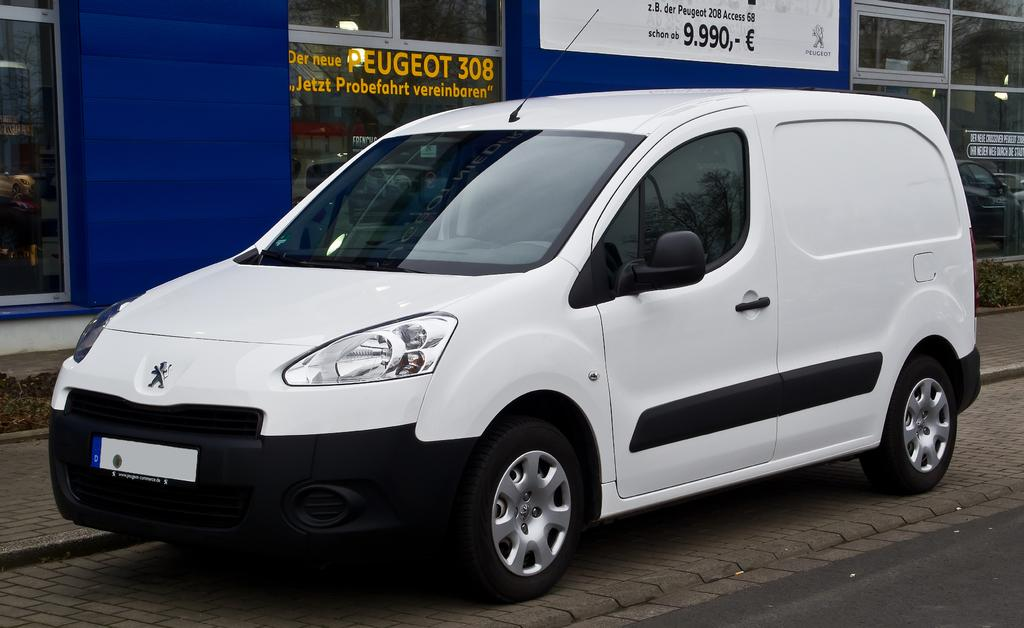Provide a one-sentence caption for the provided image. A white vehicle is in front of a window with the word Peugeot on it. 